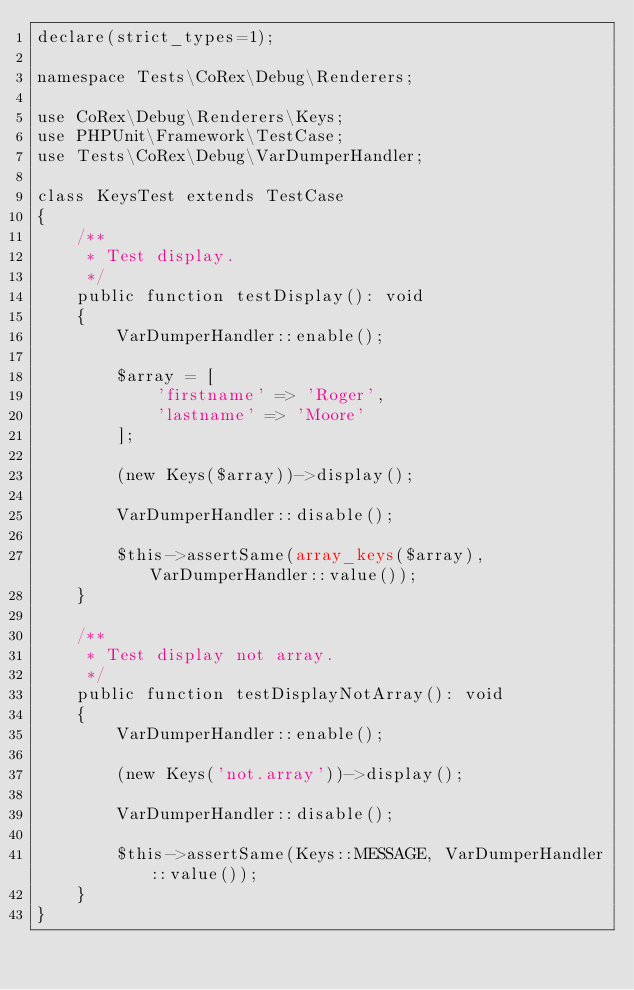Convert code to text. <code><loc_0><loc_0><loc_500><loc_500><_PHP_>declare(strict_types=1);

namespace Tests\CoRex\Debug\Renderers;

use CoRex\Debug\Renderers\Keys;
use PHPUnit\Framework\TestCase;
use Tests\CoRex\Debug\VarDumperHandler;

class KeysTest extends TestCase
{
    /**
     * Test display.
     */
    public function testDisplay(): void
    {
        VarDumperHandler::enable();

        $array = [
            'firstname' => 'Roger',
            'lastname' => 'Moore'
        ];

        (new Keys($array))->display();

        VarDumperHandler::disable();

        $this->assertSame(array_keys($array), VarDumperHandler::value());
    }

    /**
     * Test display not array.
     */
    public function testDisplayNotArray(): void
    {
        VarDumperHandler::enable();

        (new Keys('not.array'))->display();

        VarDumperHandler::disable();

        $this->assertSame(Keys::MESSAGE, VarDumperHandler::value());
    }
}</code> 